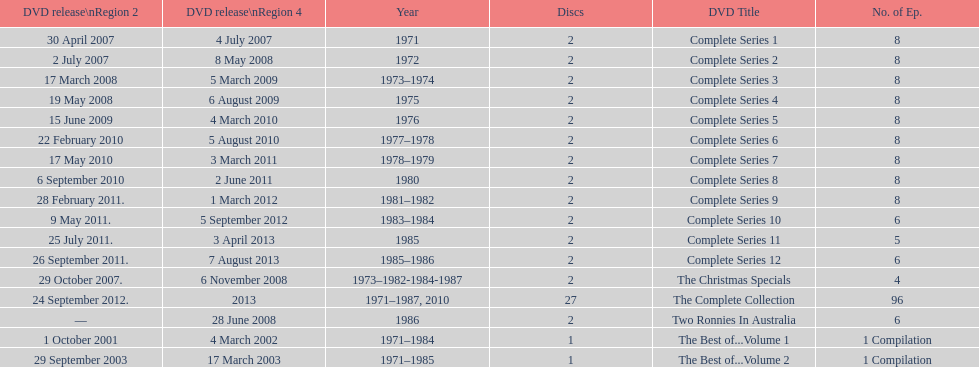The television show "the two ronnies" ran for a total of how many seasons? 12. 